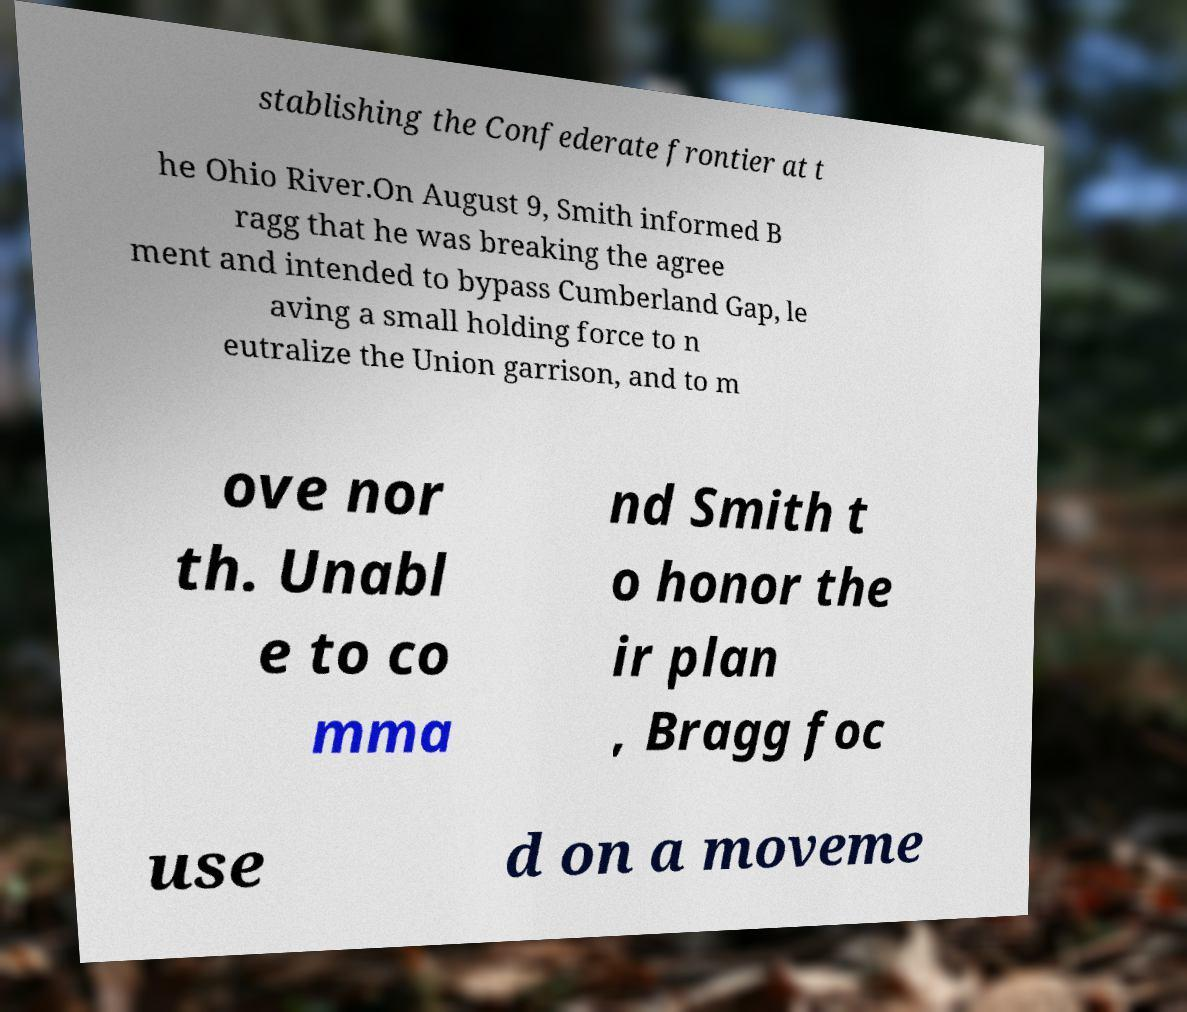Could you assist in decoding the text presented in this image and type it out clearly? stablishing the Confederate frontier at t he Ohio River.On August 9, Smith informed B ragg that he was breaking the agree ment and intended to bypass Cumberland Gap, le aving a small holding force to n eutralize the Union garrison, and to m ove nor th. Unabl e to co mma nd Smith t o honor the ir plan , Bragg foc use d on a moveme 